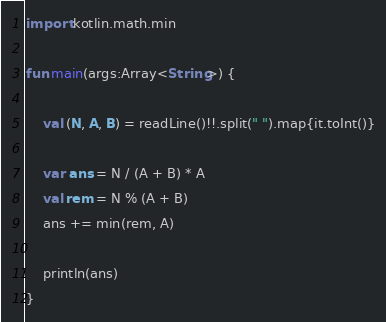<code> <loc_0><loc_0><loc_500><loc_500><_Kotlin_>import kotlin.math.min

fun main(args:Array<String>) {

    val (N, A, B) = readLine()!!.split(" ").map{it.toInt()}

    var ans = N / (A + B) * A
    val rem = N % (A + B)
    ans += min(rem, A)

    println(ans)
}
</code> 